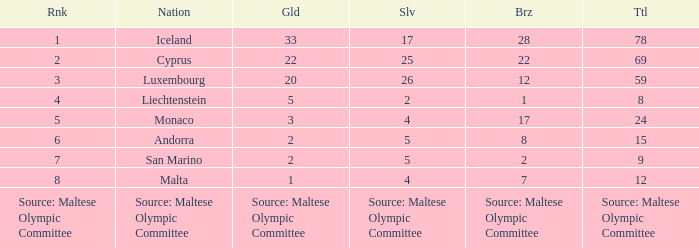Which position does the country with 2 silver medals hold in the ranking? 4.0. 